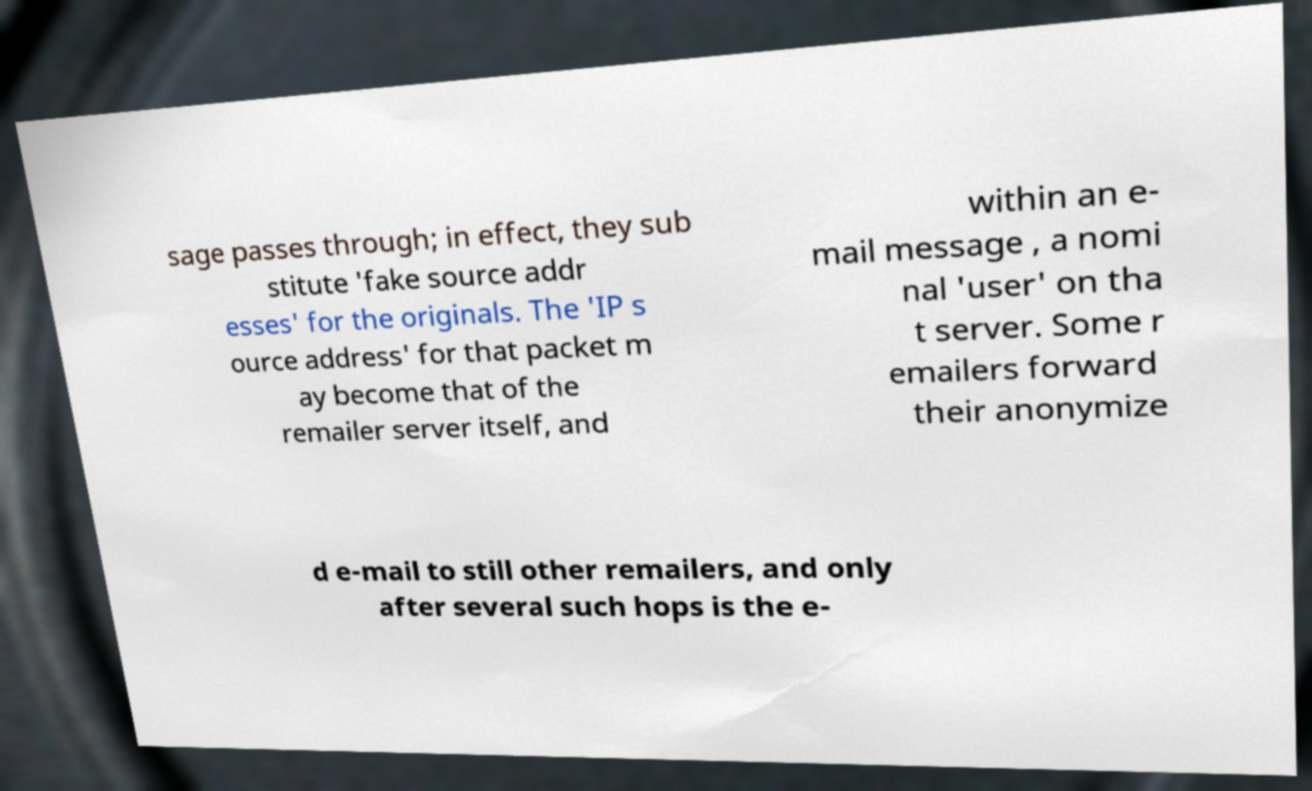Could you assist in decoding the text presented in this image and type it out clearly? sage passes through; in effect, they sub stitute 'fake source addr esses' for the originals. The 'IP s ource address' for that packet m ay become that of the remailer server itself, and within an e- mail message , a nomi nal 'user' on tha t server. Some r emailers forward their anonymize d e-mail to still other remailers, and only after several such hops is the e- 